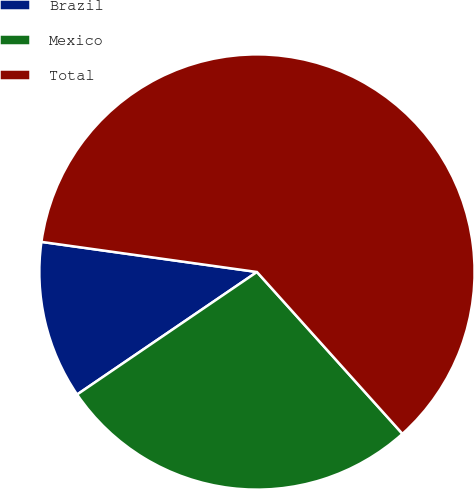<chart> <loc_0><loc_0><loc_500><loc_500><pie_chart><fcel>Brazil<fcel>Mexico<fcel>Total<nl><fcel>11.73%<fcel>27.14%<fcel>61.14%<nl></chart> 